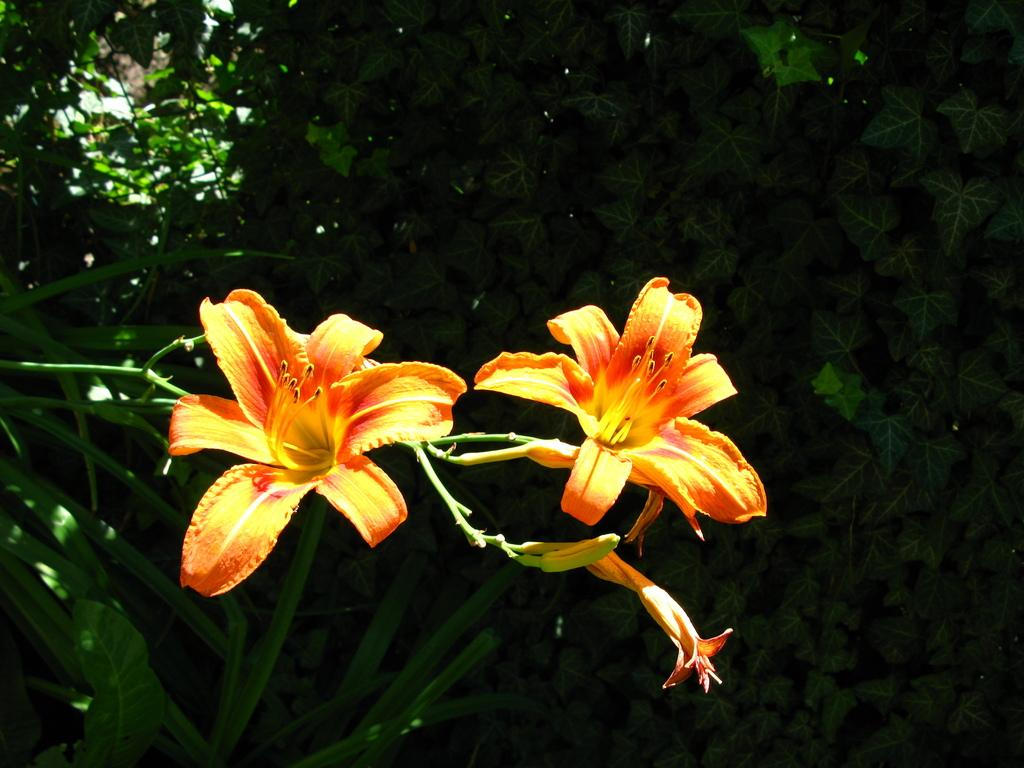What type of flowers are present in the image? There are yellow flowers in the image. What other plant elements can be seen in the image besides the flowers? There are green leaves in the image. How would you describe the lighting in the background of the image? The image appears to be slightly dark in the background. How many cherries are hanging from the leaves in the image? There are no cherries present in the image; it features yellow flowers and green leaves. Can you tell me the color of the banana in the image? There is no banana present in the image. 